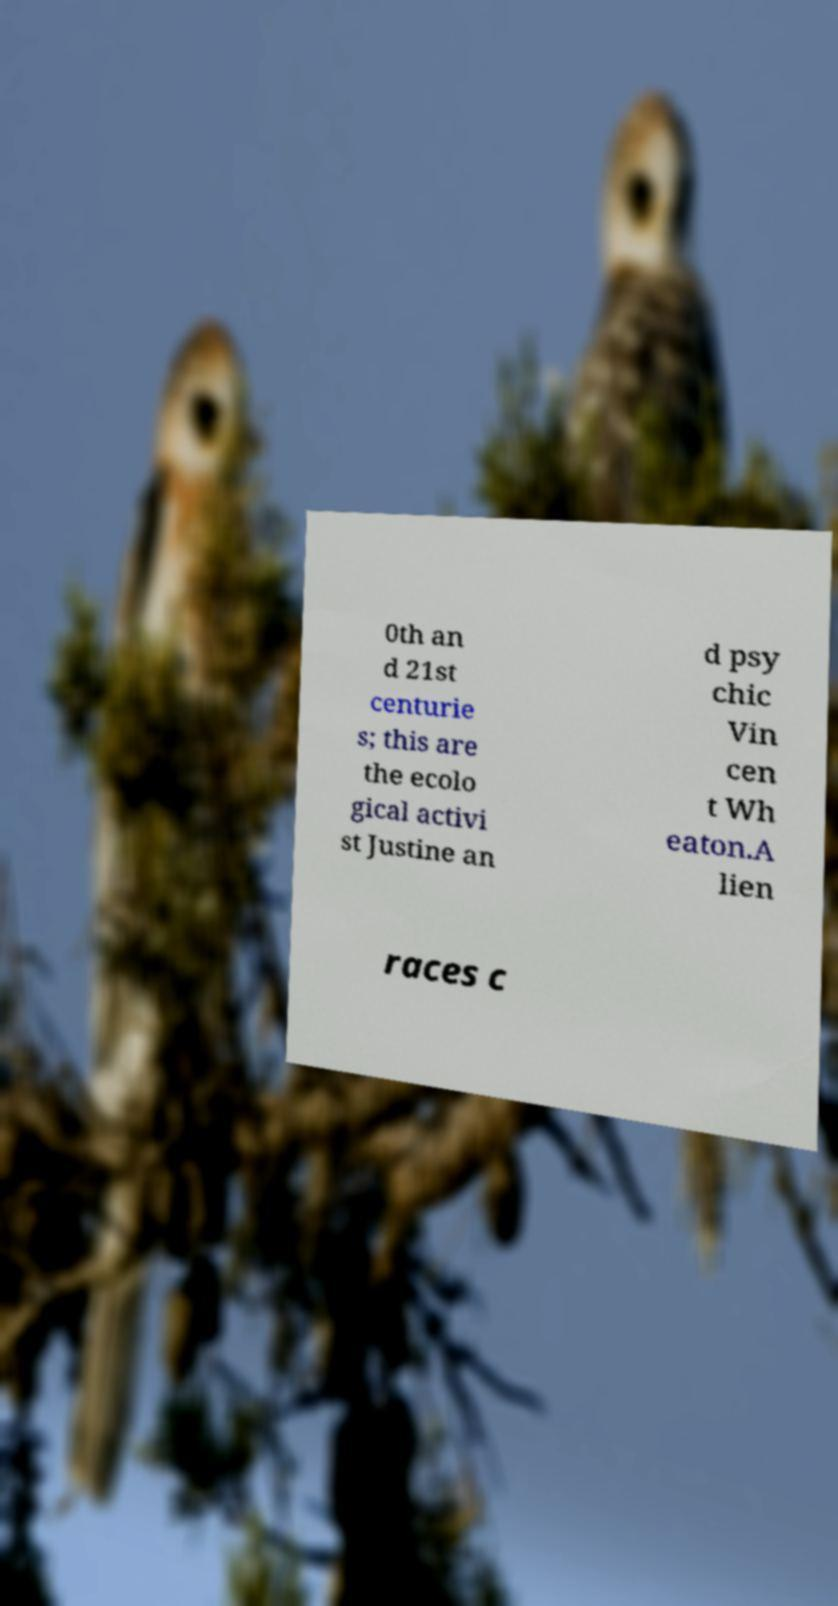There's text embedded in this image that I need extracted. Can you transcribe it verbatim? 0th an d 21st centurie s; this are the ecolo gical activi st Justine an d psy chic Vin cen t Wh eaton.A lien races c 